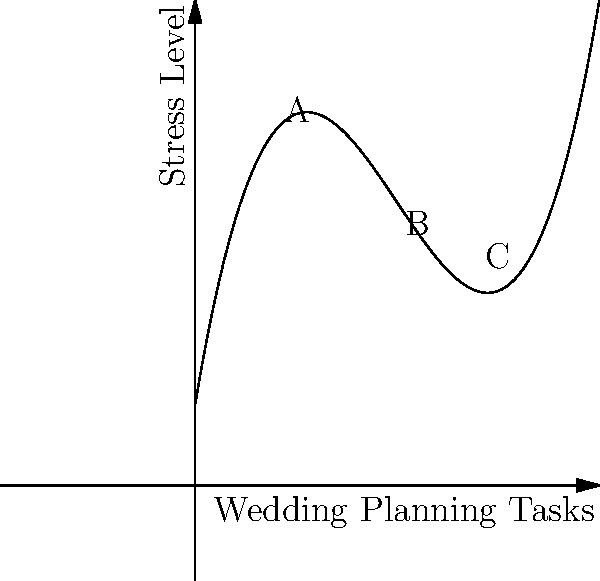The graph represents the relationship between the number of wedding planning tasks completed (x-axis) and the stress level experienced by couples (y-axis). Analyze the graph and determine at which point (A, B, or C) the rate of change in stress level is the highest as more tasks are completed. To determine where the rate of change in stress level is highest, we need to analyze the slope of the curve at points A, B, and C:

1. Point A (early stages): The curve has a negative slope, indicating that stress decreases as initial tasks are completed.

2. Point B (middle stages): The curve has a relatively flat slope, suggesting a period of stable stress levels.

3. Point C (later stages): The curve has a steep positive slope, indicating rapidly increasing stress as the number of tasks grows.

The rate of change is represented by the steepness of the slope. The steeper the slope, the higher the rate of change.

Comparing the slopes at A, B, and C, we can see that point C has the steepest slope, indicating the highest rate of change in stress levels.

This aligns with the common experience of wedding planning, where stress tends to escalate rapidly as the wedding date approaches and the number of remaining tasks increases.
Answer: C 